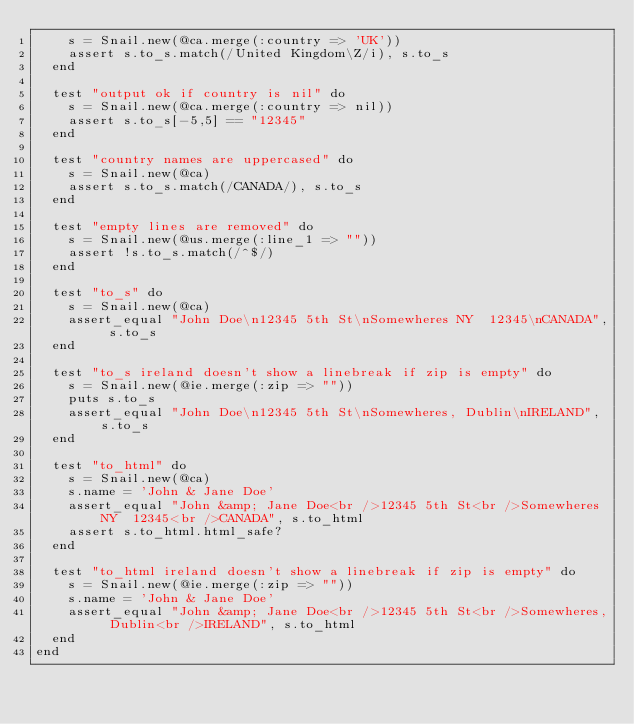<code> <loc_0><loc_0><loc_500><loc_500><_Ruby_>    s = Snail.new(@ca.merge(:country => 'UK'))
    assert s.to_s.match(/United Kingdom\Z/i), s.to_s
  end

  test "output ok if country is nil" do
    s = Snail.new(@ca.merge(:country => nil))
    assert s.to_s[-5,5] == "12345"
  end

  test "country names are uppercased" do
    s = Snail.new(@ca)
    assert s.to_s.match(/CANADA/), s.to_s
  end

  test "empty lines are removed" do
    s = Snail.new(@us.merge(:line_1 => ""))
    assert !s.to_s.match(/^$/)
  end

  test "to_s" do
    s = Snail.new(@ca)
    assert_equal "John Doe\n12345 5th St\nSomewheres NY  12345\nCANADA", s.to_s
  end

  test "to_s ireland doesn't show a linebreak if zip is empty" do
    s = Snail.new(@ie.merge(:zip => ""))
    puts s.to_s
    assert_equal "John Doe\n12345 5th St\nSomewheres, Dublin\nIRELAND", s.to_s
  end

  test "to_html" do
    s = Snail.new(@ca)
    s.name = 'John & Jane Doe'
    assert_equal "John &amp; Jane Doe<br />12345 5th St<br />Somewheres NY  12345<br />CANADA", s.to_html
    assert s.to_html.html_safe?
  end

  test "to_html ireland doesn't show a linebreak if zip is empty" do
    s = Snail.new(@ie.merge(:zip => ""))
    s.name = 'John & Jane Doe'
    assert_equal "John &amp; Jane Doe<br />12345 5th St<br />Somewheres, Dublin<br />IRELAND", s.to_html
  end
end


</code> 